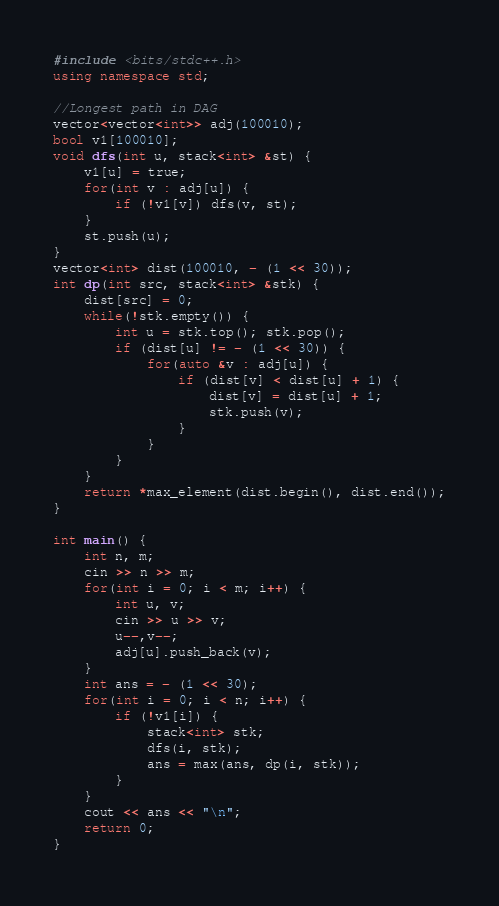<code> <loc_0><loc_0><loc_500><loc_500><_C++_>#include <bits/stdc++.h>
using namespace std;

//Longest path in DAG
vector<vector<int>> adj(100010);
bool v1[100010];
void dfs(int u, stack<int> &st) {
    v1[u] = true;
    for(int v : adj[u]) {
        if (!v1[v]) dfs(v, st);
    }
    st.push(u);
}
vector<int> dist(100010, - (1 << 30));
int dp(int src, stack<int> &stk) {
    dist[src] = 0;
    while(!stk.empty()) {
        int u = stk.top(); stk.pop();
        if (dist[u] != - (1 << 30)) {
            for(auto &v : adj[u]) {
                if (dist[v] < dist[u] + 1) {
                    dist[v] = dist[u] + 1;
                    stk.push(v);
                }
            }
        }
    }
    return *max_element(dist.begin(), dist.end());
}

int main() {
    int n, m;
    cin >> n >> m;
    for(int i = 0; i < m; i++) {
        int u, v;
        cin >> u >> v;
        u--,v--;
        adj[u].push_back(v);
    }
    int ans = - (1 << 30);
    for(int i = 0; i < n; i++) {
        if (!v1[i]) {
            stack<int> stk;
            dfs(i, stk);
            ans = max(ans, dp(i, stk));
        }
    }
    cout << ans << "\n";
    return 0;
}
</code> 